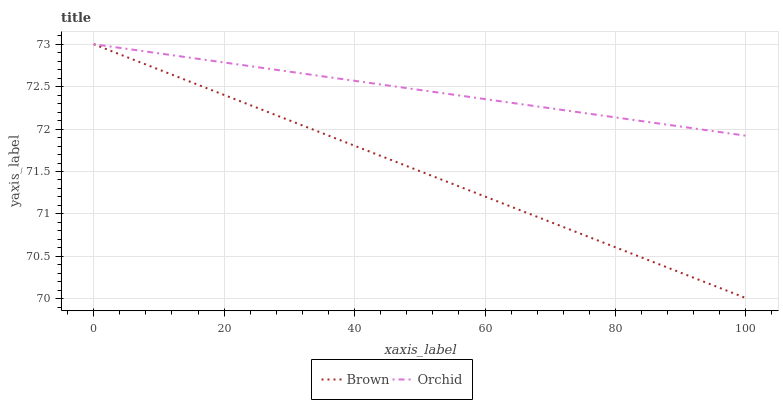Does Orchid have the minimum area under the curve?
Answer yes or no. No. Is Orchid the roughest?
Answer yes or no. No. Does Orchid have the lowest value?
Answer yes or no. No. 